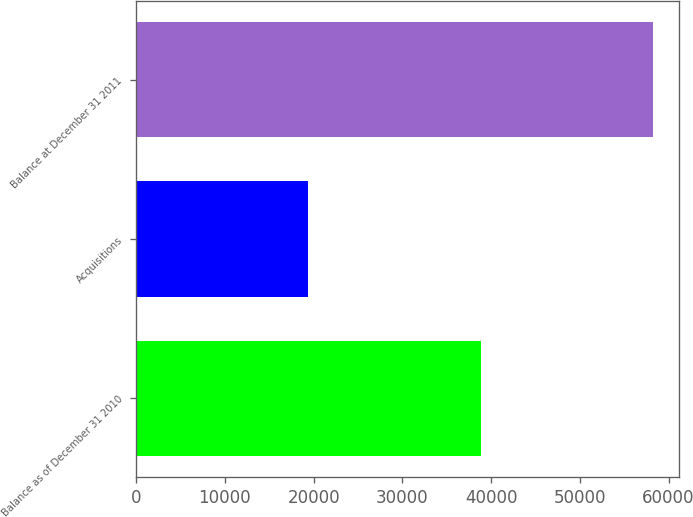Convert chart. <chart><loc_0><loc_0><loc_500><loc_500><bar_chart><fcel>Balance as of December 31 2010<fcel>Acquisitions<fcel>Balance at December 31 2011<nl><fcel>38854<fcel>19360<fcel>58214<nl></chart> 